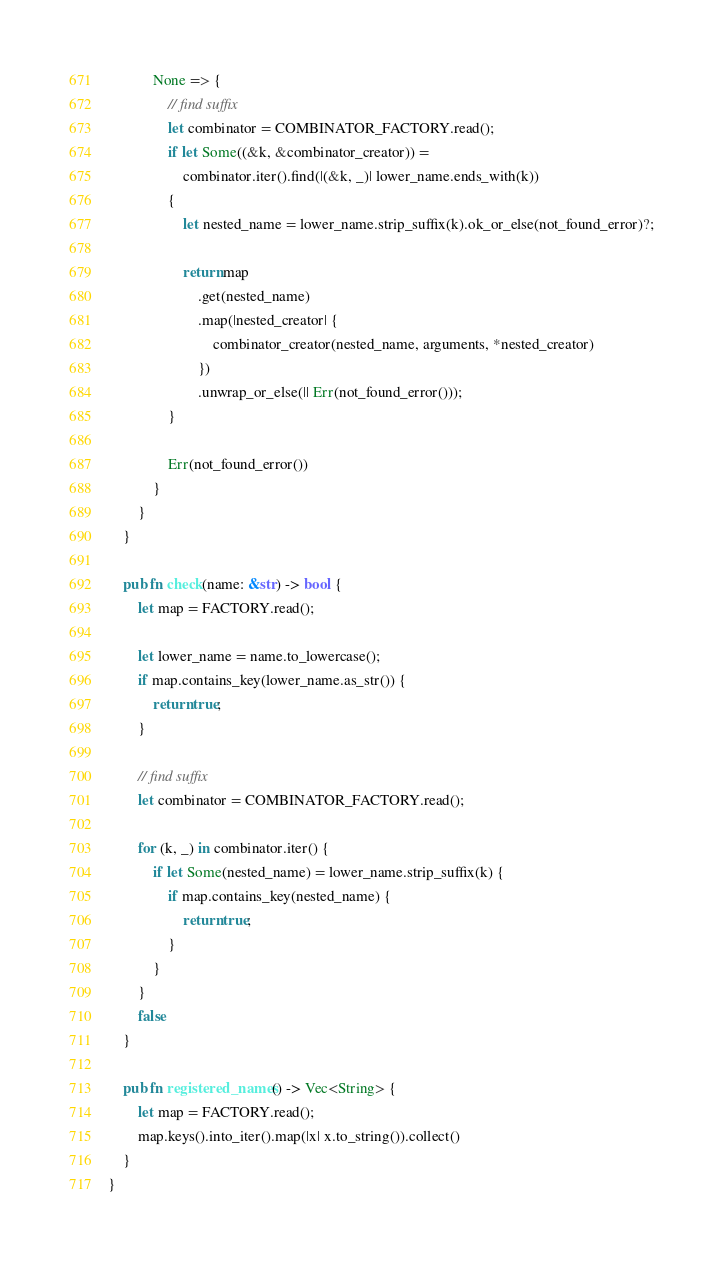Convert code to text. <code><loc_0><loc_0><loc_500><loc_500><_Rust_>            None => {
                // find suffix
                let combinator = COMBINATOR_FACTORY.read();
                if let Some((&k, &combinator_creator)) =
                    combinator.iter().find(|(&k, _)| lower_name.ends_with(k))
                {
                    let nested_name = lower_name.strip_suffix(k).ok_or_else(not_found_error)?;

                    return map
                        .get(nested_name)
                        .map(|nested_creator| {
                            combinator_creator(nested_name, arguments, *nested_creator)
                        })
                        .unwrap_or_else(|| Err(not_found_error()));
                }

                Err(not_found_error())
            }
        }
    }

    pub fn check(name: &str) -> bool {
        let map = FACTORY.read();

        let lower_name = name.to_lowercase();
        if map.contains_key(lower_name.as_str()) {
            return true;
        }

        // find suffix
        let combinator = COMBINATOR_FACTORY.read();

        for (k, _) in combinator.iter() {
            if let Some(nested_name) = lower_name.strip_suffix(k) {
                if map.contains_key(nested_name) {
                    return true;
                }
            }
        }
        false
    }

    pub fn registered_names() -> Vec<String> {
        let map = FACTORY.read();
        map.keys().into_iter().map(|x| x.to_string()).collect()
    }
}
</code> 